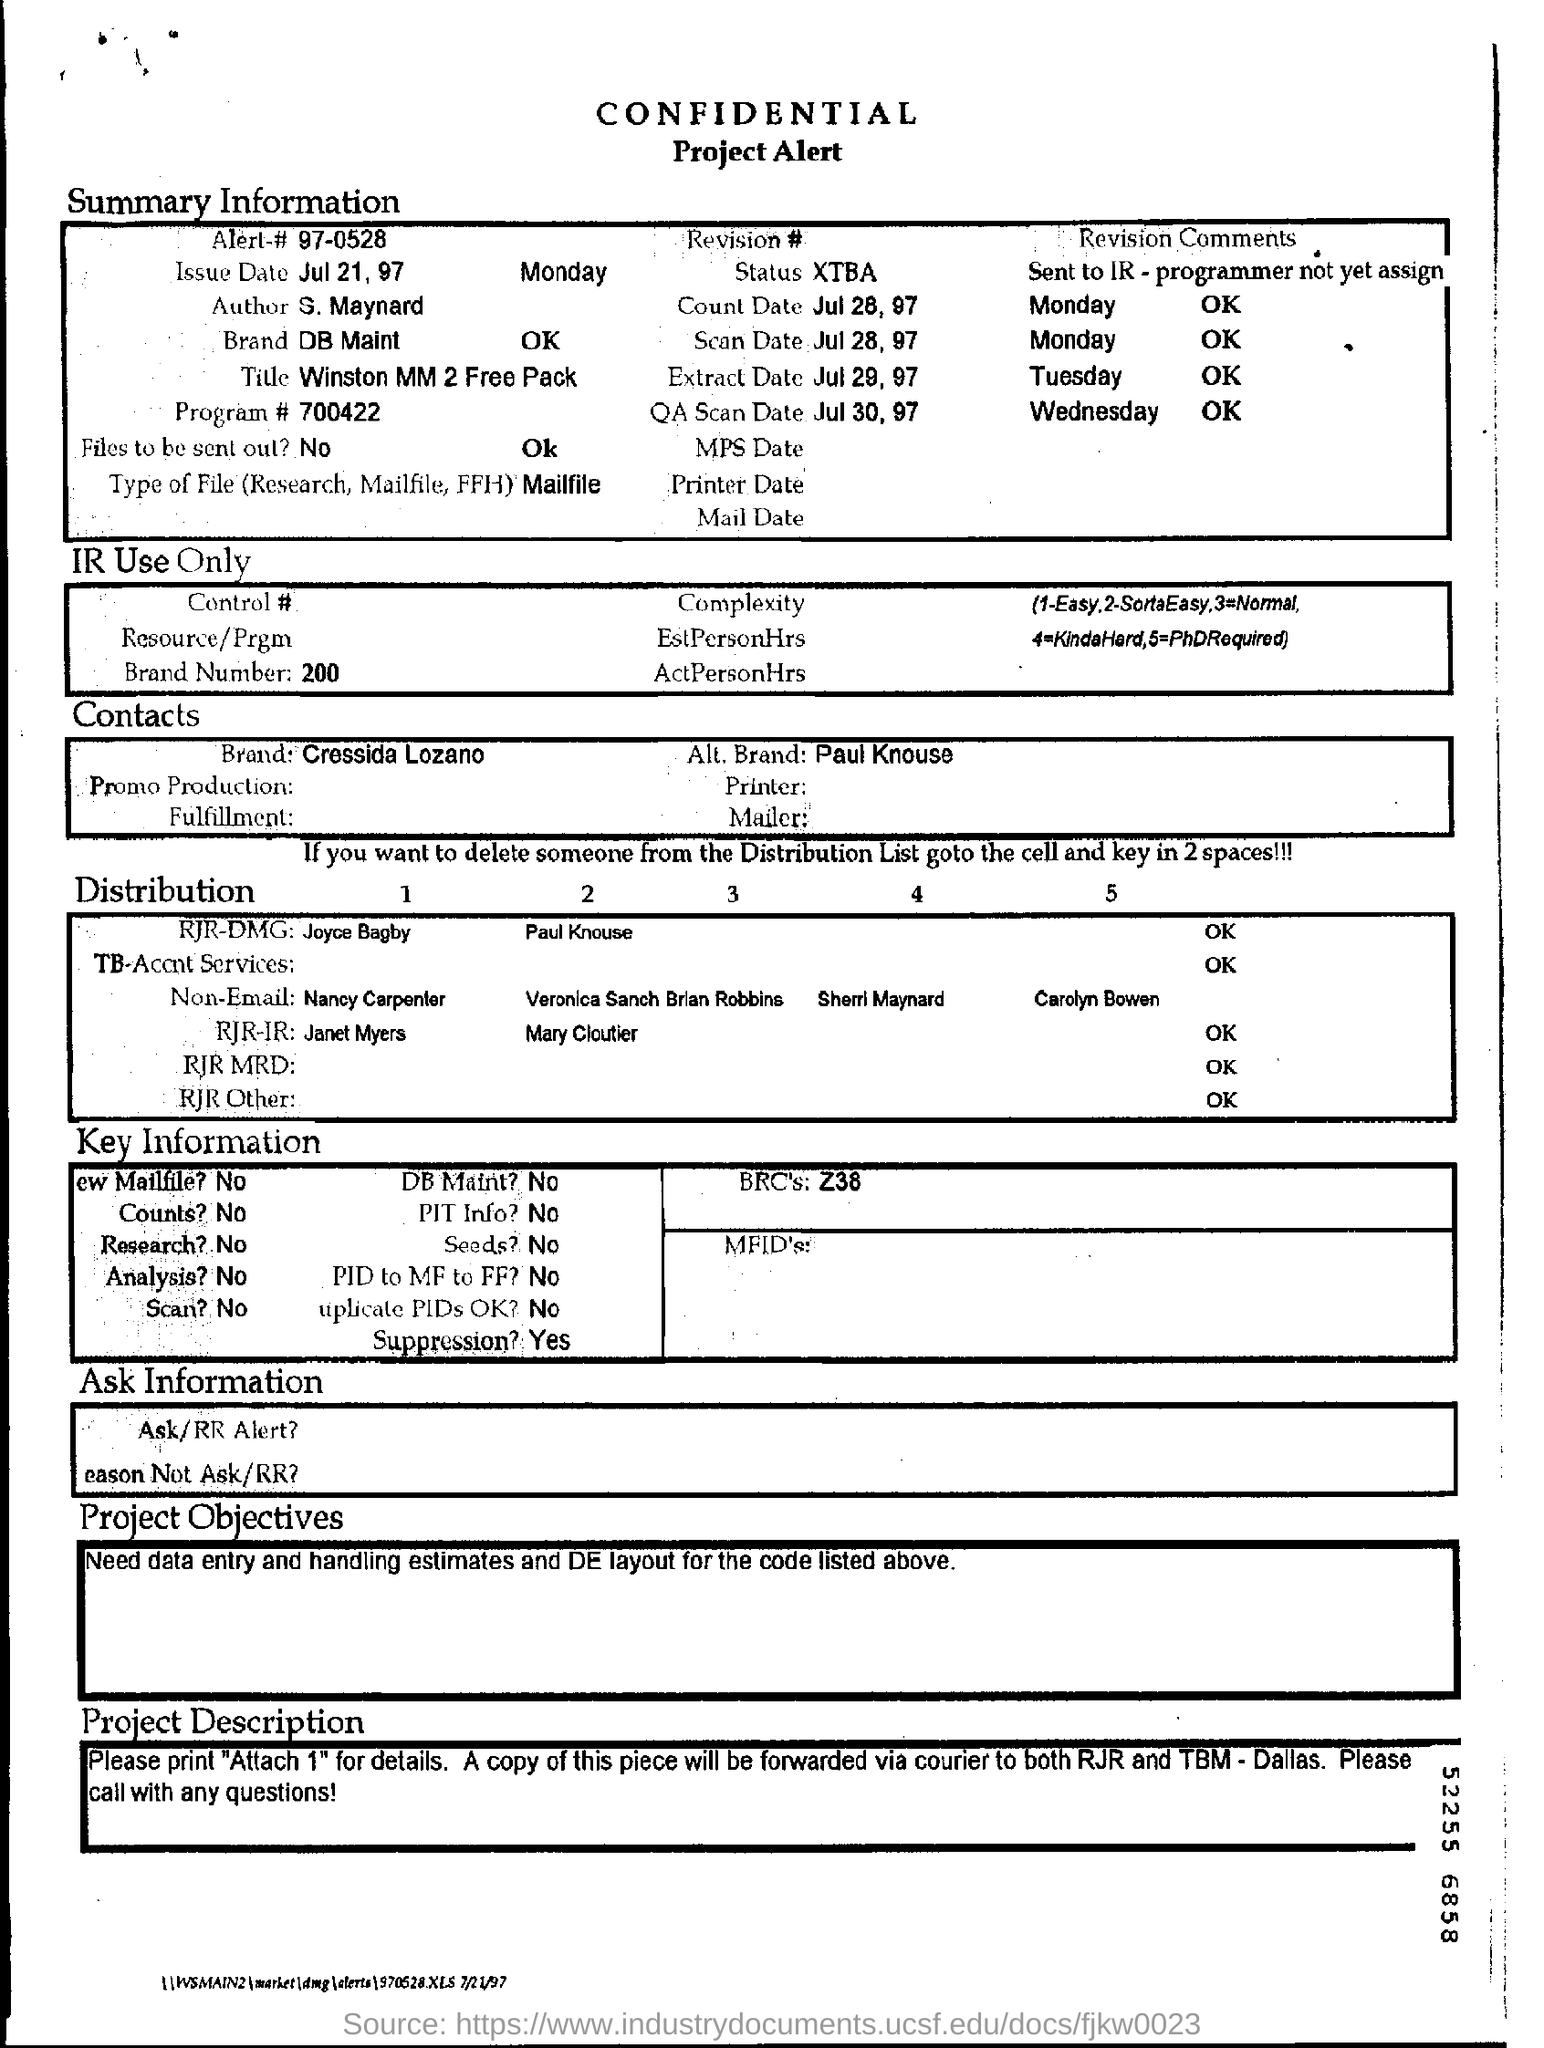What is the Issue Date mentioned in the Summary Information?
Ensure brevity in your answer.  Jul 21, 97. What is the name of the Brand mentioned in the Contacts?
Your answer should be compact. Cressida Lozano. Are the files meant to be sent out?
Your answer should be very brief. No. 